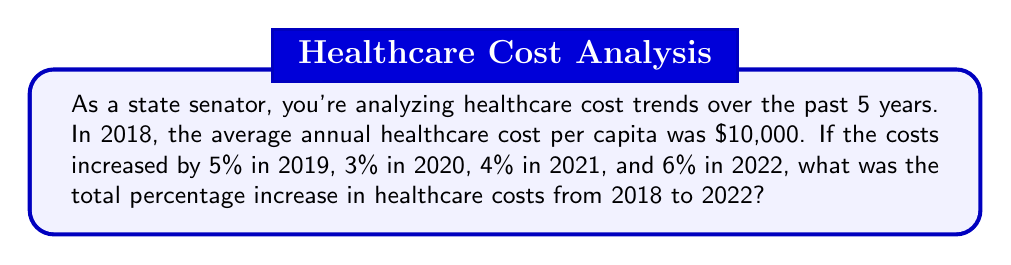Give your solution to this math problem. Let's approach this step-by-step:

1) First, we need to calculate the cumulative effect of these percentage increases. We do this by multiplying the factors for each year:

   $$(1 + 0.05) \times (1 + 0.03) \times (1 + 0.04) \times (1 + 0.06)$$

2) Let's calculate this:
   $$1.05 \times 1.03 \times 1.04 \times 1.06 = 1.1940$$

3) This factor of 1.1940 represents the total increase over the 4-year period.

4) To convert this to a percentage increase, we subtract 1 and multiply by 100:

   $$(1.1940 - 1) \times 100 = 0.1940 \times 100 = 19.40\%$$

Therefore, the total percentage increase in healthcare costs from 2018 to 2022 was 19.40%.
Answer: 19.40% 